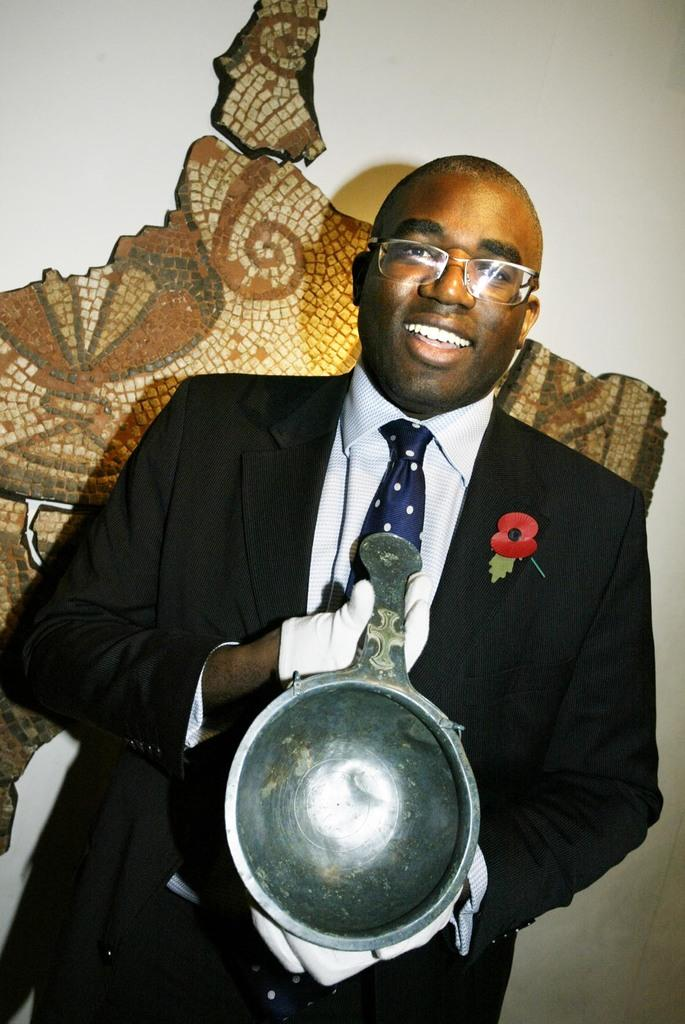Who or what is present in the image? There is a person in the image. What is the person doing in the image? The person is holding an object. What can be seen on the wall in the background of the image? There is something on the wall in the background of the image. What type of pan is visible in the person's eye in the image? There is no pan visible in the person's eye in the image. What type of trade is being conducted in the image? The image does not depict any trade or transaction. 